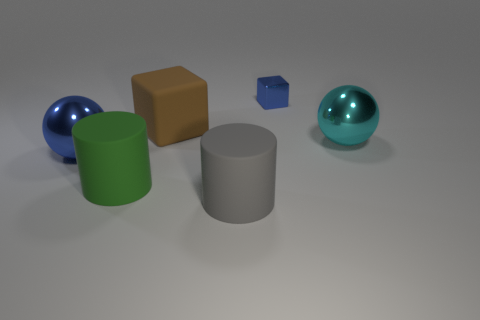Add 3 spheres. How many objects exist? 9 Subtract all cylinders. How many objects are left? 4 Subtract all cyan spheres. Subtract all large green rubber things. How many objects are left? 4 Add 1 large green cylinders. How many large green cylinders are left? 2 Add 2 rubber objects. How many rubber objects exist? 5 Subtract 0 green cubes. How many objects are left? 6 